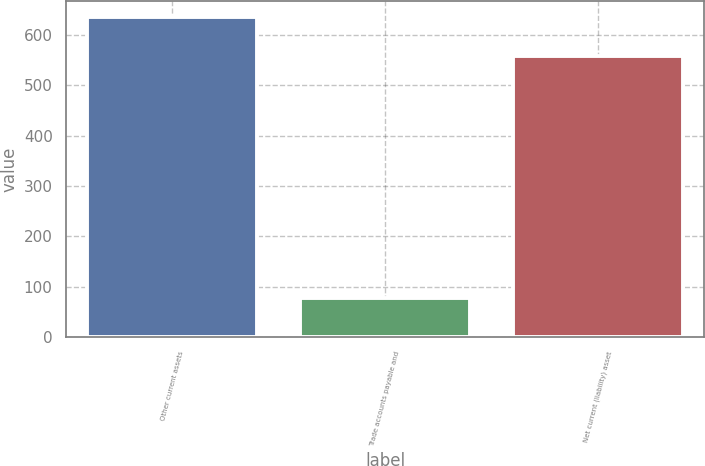Convert chart. <chart><loc_0><loc_0><loc_500><loc_500><bar_chart><fcel>Other current assets<fcel>Trade accounts payable and<fcel>Net current (liability) asset<nl><fcel>635<fcel>77<fcel>558<nl></chart> 